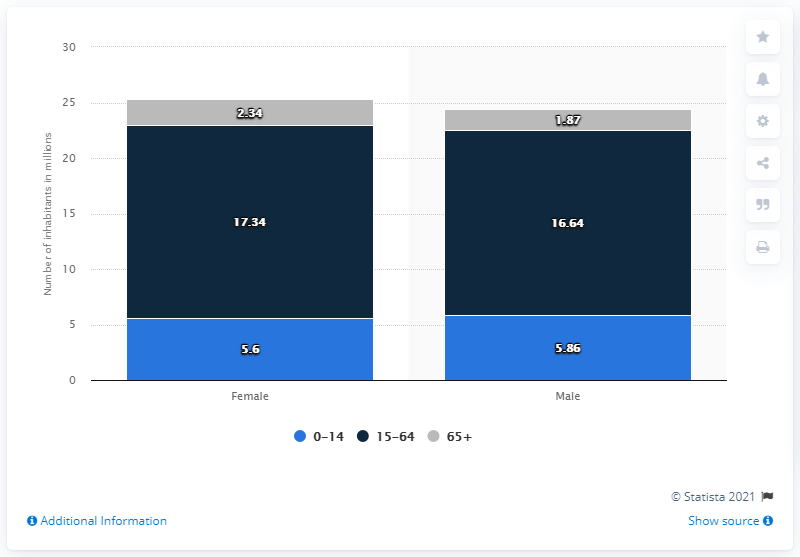Point out several critical features in this image. The difference in numbers between the male and female population of Colombia in 2018 across all age groups was 0.91. In Colombia, approximately 5.6% of the female population is between the ages of 0-14. 